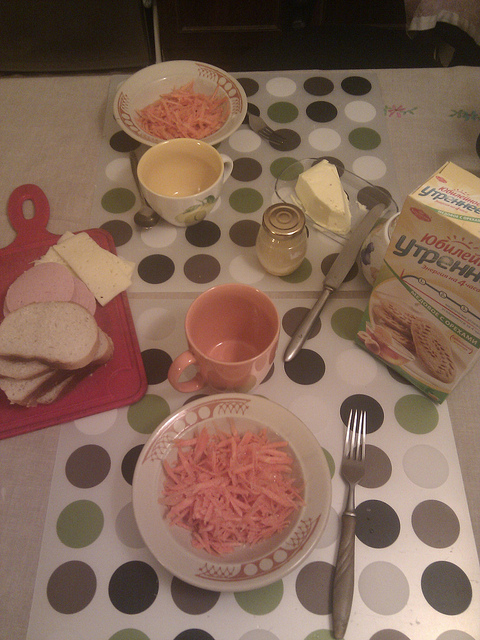<image>What is the food called on the right? I am not sure what the food is called on the right. It could be cereal, butter, pancakes, crackers, ham, pasta or bread. Is this for a wedding or a kids birthday party? It is ambiguous but it looks like this could be for a kid's birthday party. What is the food called on the right? I don't know what the food is called on the right. It could be cereal, butter, pancakes, crackers, ham, pasta, or bread. Is this for a wedding or a kids birthday party? It is ambiguous if this is for a wedding or a kids birthday party. It can be both. 